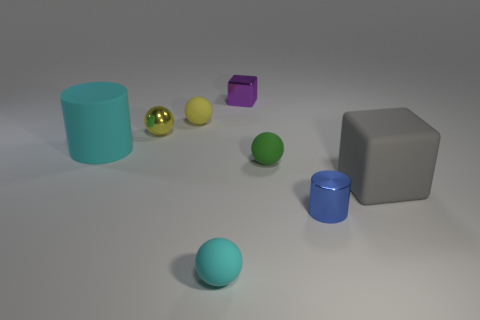Do the tiny green matte thing and the tiny matte object that is behind the small yellow metallic object have the same shape?
Offer a very short reply. Yes. Is there a big cube of the same color as the tiny shiny sphere?
Give a very brief answer. No. How many balls are either small rubber objects or tiny things?
Provide a succinct answer. 4. Are there any gray objects that have the same shape as the tiny purple metal object?
Give a very brief answer. Yes. How many other things are there of the same color as the metallic ball?
Provide a short and direct response. 1. Is the number of big cyan objects that are to the right of the purple block less than the number of tiny yellow metallic balls?
Provide a succinct answer. Yes. How many small purple cubes are there?
Ensure brevity in your answer.  1. What number of small blue things are made of the same material as the purple cube?
Make the answer very short. 1. What number of objects are either balls that are behind the large gray matte block or tiny green cubes?
Ensure brevity in your answer.  3. Are there fewer large objects right of the yellow shiny object than cubes that are behind the small purple shiny block?
Provide a short and direct response. No. 